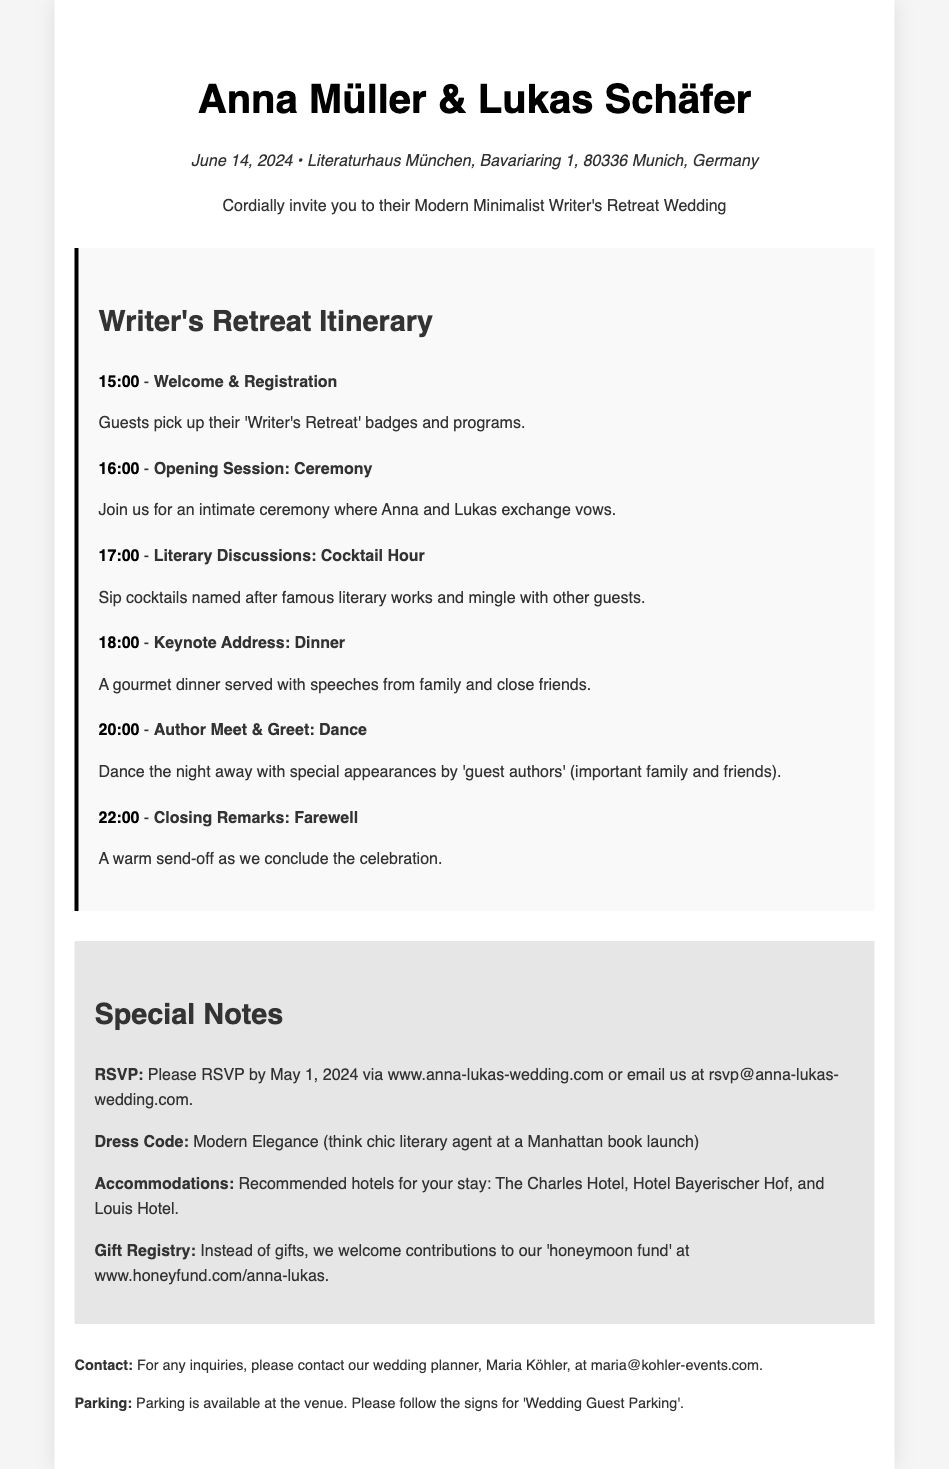What is the wedding date? The wedding date is explicitly mentioned in the document as June 14, 2024.
Answer: June 14, 2024 Where is the wedding venue located? The venue is listed in the document, indicating the location as Literaturhaus München.
Answer: Literaturhaus München What time does the ceremony begin? The ceremony time is specified in the itinerary as 16:00.
Answer: 16:00 What is the dress code for the wedding? The document includes a note on dress code, specifying "Modern Elegance."
Answer: Modern Elegance Who is the wedding planner? The contact information section reveals the name of the wedding planner.
Answer: Maria Köhler What should guests do for RSVP? The RSVP instructions are provided in the special notes section.
Answer: www.anna-lukas-wedding.com What is the theme of the wedding invitation? The theme of the invitation is indicated within the description as a "Modern Minimalist Writer's Retreat Wedding."
Answer: Modern Minimalist Writer's Retreat How many events are listed in the itinerary? The itinerary includes six distinct events, which can be counted in the listed agenda.
Answer: Six events 